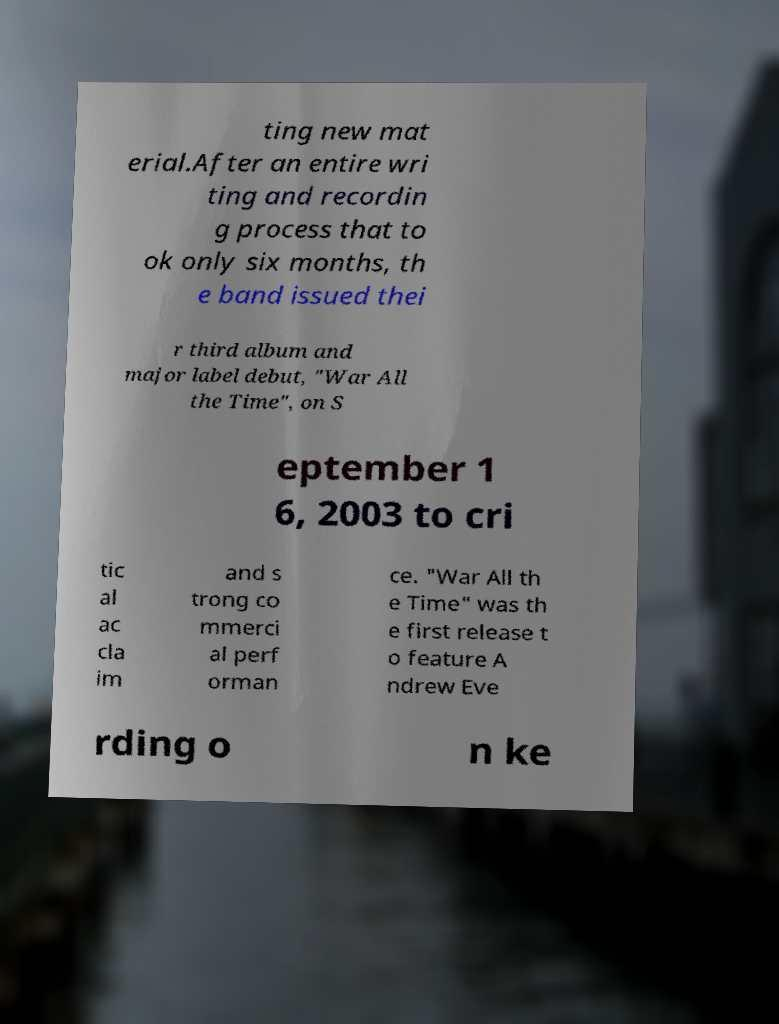For documentation purposes, I need the text within this image transcribed. Could you provide that? ting new mat erial.After an entire wri ting and recordin g process that to ok only six months, th e band issued thei r third album and major label debut, "War All the Time", on S eptember 1 6, 2003 to cri tic al ac cla im and s trong co mmerci al perf orman ce. "War All th e Time" was th e first release t o feature A ndrew Eve rding o n ke 